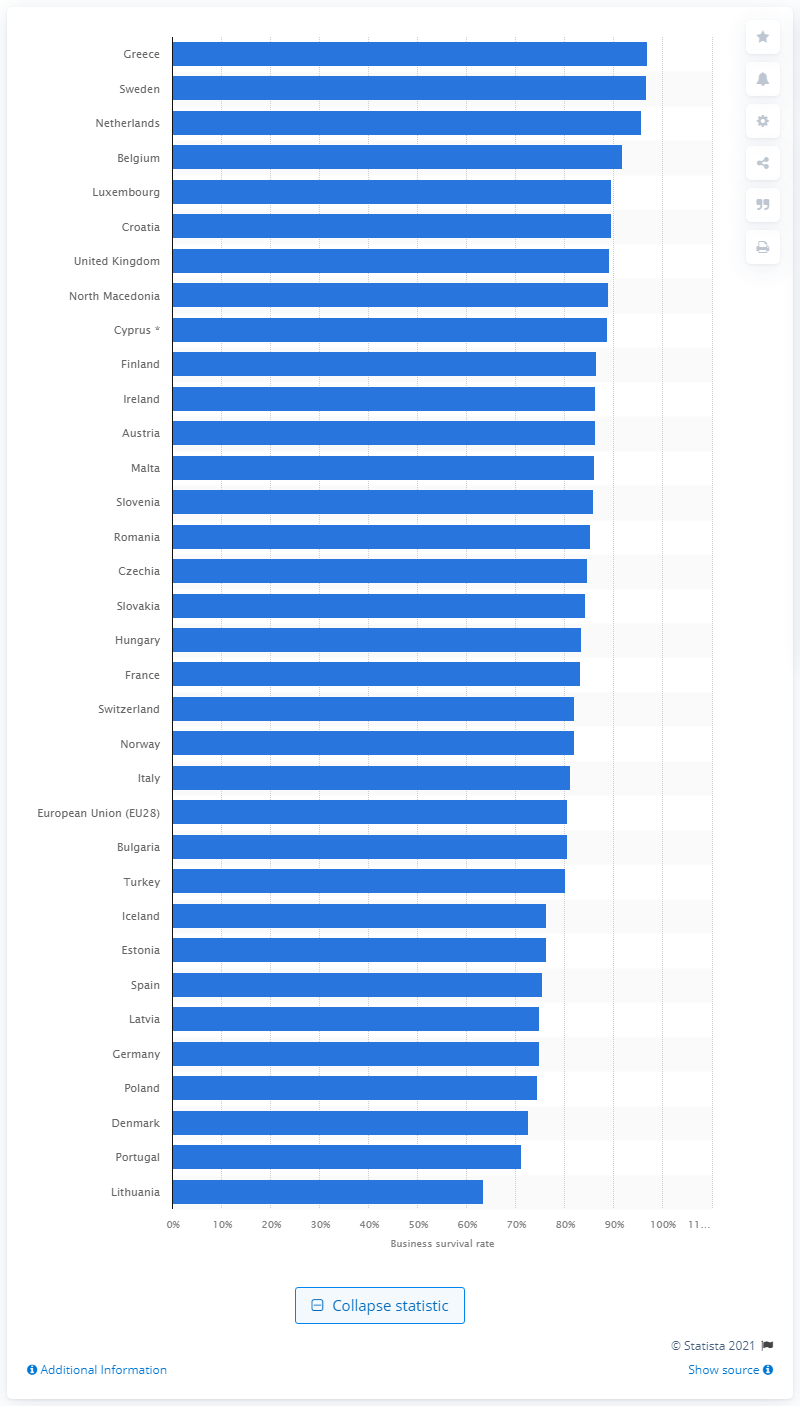Specify some key components in this picture. According to a recent survey, Greece had the highest business survival rate in 2018, among all the countries. 